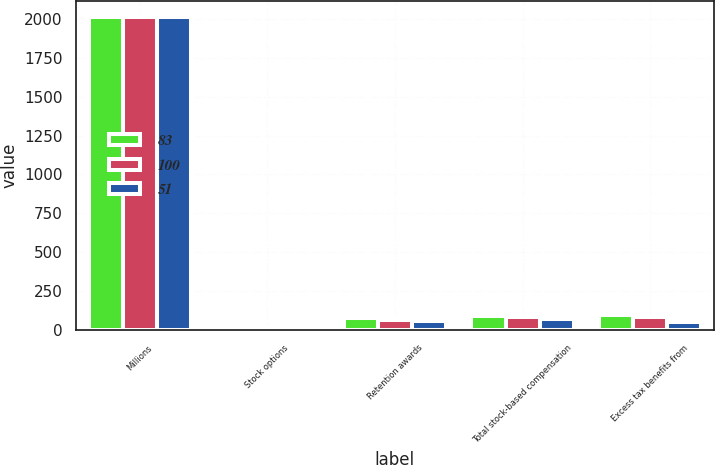Convert chart. <chart><loc_0><loc_0><loc_500><loc_500><stacked_bar_chart><ecel><fcel>Millions<fcel>Stock options<fcel>Retention awards<fcel>Total stock-based compensation<fcel>Excess tax benefits from<nl><fcel>83<fcel>2012<fcel>18<fcel>75<fcel>93<fcel>100<nl><fcel>100<fcel>2011<fcel>18<fcel>64<fcel>82<fcel>83<nl><fcel>51<fcel>2010<fcel>17<fcel>57<fcel>74<fcel>51<nl></chart> 